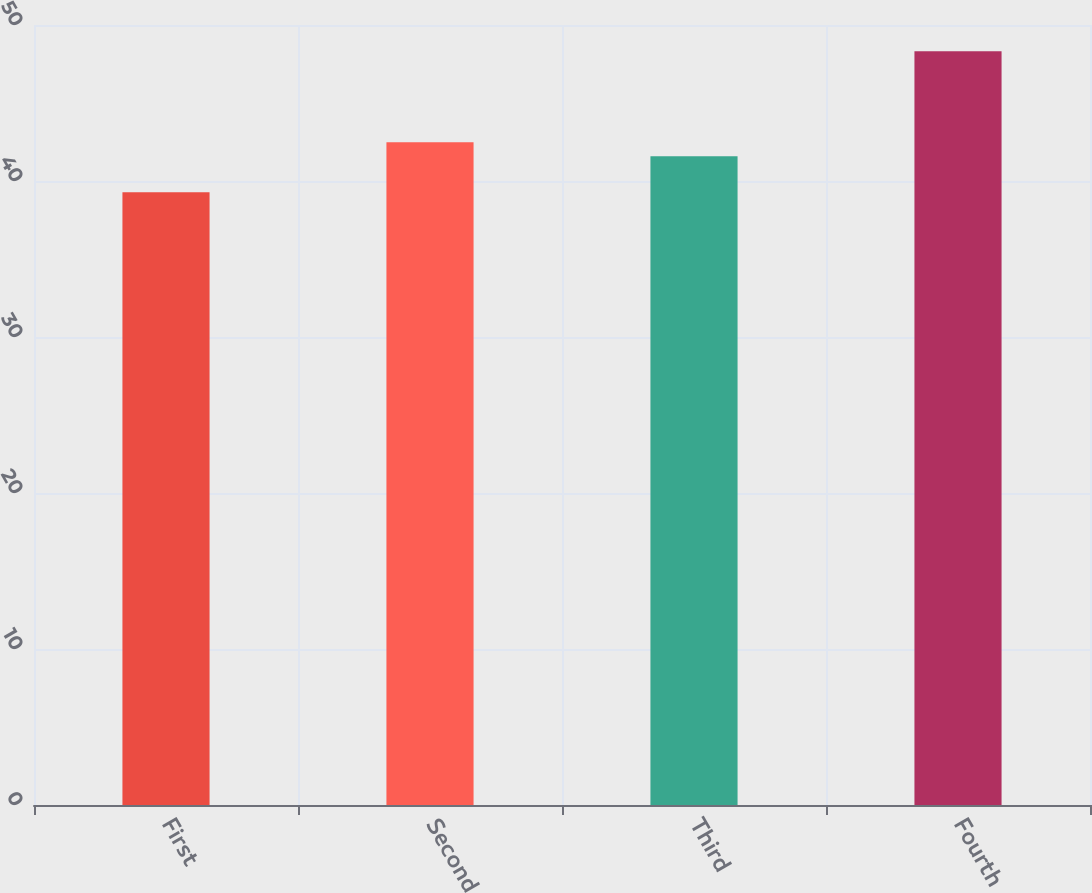<chart> <loc_0><loc_0><loc_500><loc_500><bar_chart><fcel>First<fcel>Second<fcel>Third<fcel>Fourth<nl><fcel>39.28<fcel>42.49<fcel>41.59<fcel>48.31<nl></chart> 